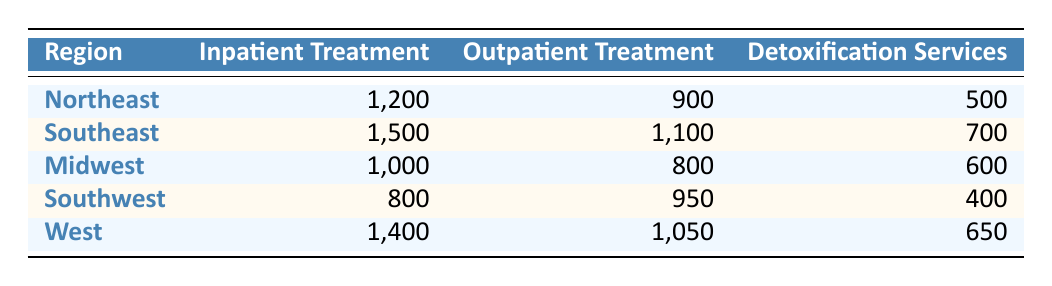What region has the highest number of inpatient treatment visits? Looking at the Inpatient Treatment column, the Southeast has the highest value at 1,500 visits compared to other regions.
Answer: Southeast Which region has the lowest number of detoxification services visits? Comparing the Detoxification Services column, the Southwest has the lowest value at 400 visits.
Answer: Southwest What is the total number of outpatient treatment visits across all regions? To calculate the total, we sum the Outpatient Treatment visits: 900 (Northeast) + 1,100 (Southeast) + 800 (Midwest) + 950 (Southwest) + 1,050 (West) = 4,800 visits.
Answer: 4,800 Is the number of outpatient treatment visits higher in the West than in the Midwest? The West has 1,050 visits while the Midwest has 800 visits, so yes, the West has a higher number of outpatient treatment visits.
Answer: Yes What is the average number of inpatient treatment visits across all regions? We first sum the inpatient visits: 1,200 (Northeast) + 1,500 (Southeast) + 1,000 (Midwest) + 800 (Southwest) + 1,400 (West) = 5,900 visits. Dividing by the number of regions (5), we get an average of 5,900 / 5 = 1,180 visits.
Answer: 1,180 Which type of service has the highest total visits across all regions? We need to sum all visits for each service: Inpatient: 5,900, Outpatient: 4,800, Detoxification: 3,300. Inpatient Treatment has the highest total at 5,900 visits.
Answer: Inpatient Treatment Does the Northeast have more detoxification services visits than the Southwest? The Northeast has 500 visits while the Southwest has 400 visits, so true, the Northeast has more visits.
Answer: Yes If you compare the total visits of inpatient and outpatient treatments for the Midwest, which is higher? Inpatient visits in the Midwest are 1,000 and outpatient visits are 800. Since 1,000 is greater than 800, inpatient visits are higher.
Answer: Inpatient How many more detoxification services visits does the Southeast have compared to the Southwest? The Southeast has 700 visits and the Southwest has 400 visits. Subtracting gives 700 - 400 = 300 more visits in the Southeast.
Answer: 300 